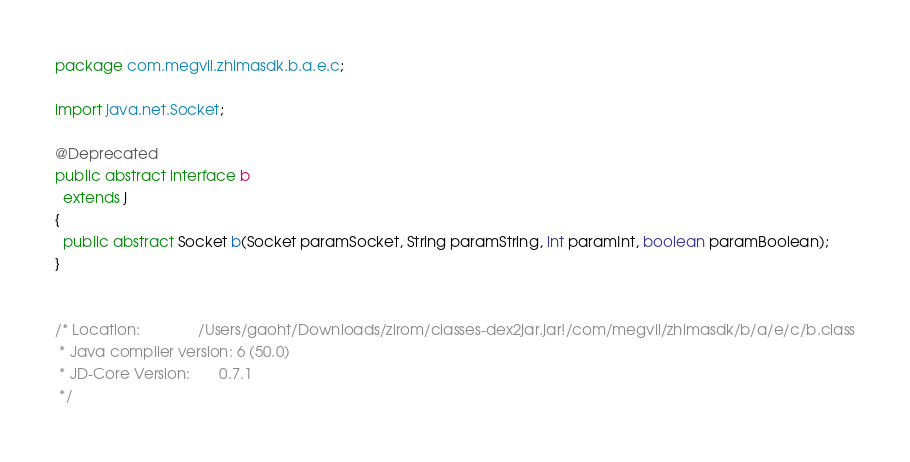<code> <loc_0><loc_0><loc_500><loc_500><_Java_>package com.megvii.zhimasdk.b.a.e.c;

import java.net.Socket;

@Deprecated
public abstract interface b
  extends j
{
  public abstract Socket b(Socket paramSocket, String paramString, int paramInt, boolean paramBoolean);
}


/* Location:              /Users/gaoht/Downloads/zirom/classes-dex2jar.jar!/com/megvii/zhimasdk/b/a/e/c/b.class
 * Java compiler version: 6 (50.0)
 * JD-Core Version:       0.7.1
 */</code> 